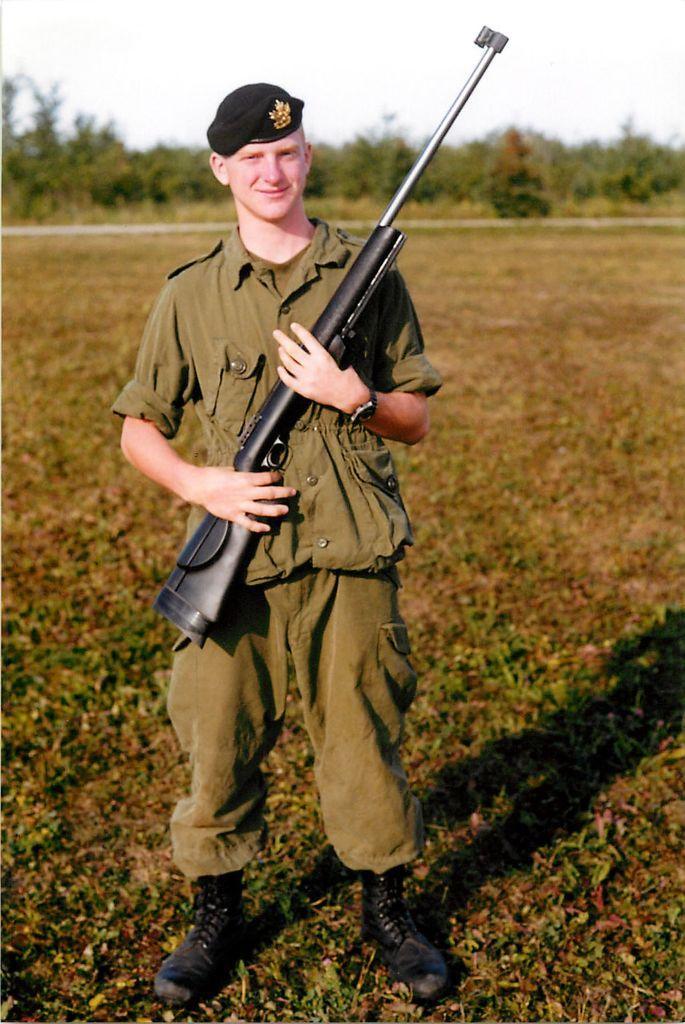Describe this image in one or two sentences. In this image, we can see a person standing and holding a gun with his hands. This person is wearing clothes and hat. In the background of the image, we can see some plants and sky. 